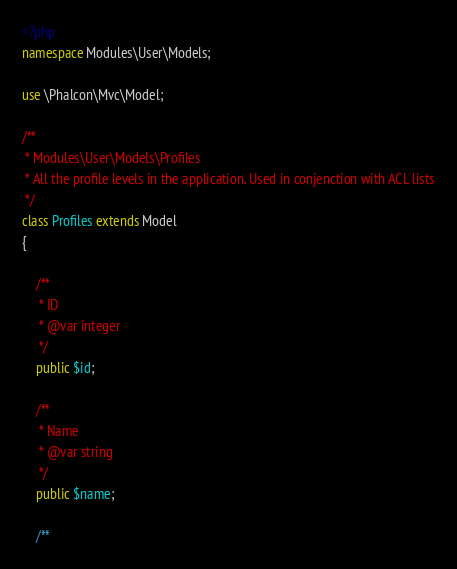<code> <loc_0><loc_0><loc_500><loc_500><_PHP_><?php
namespace Modules\User\Models;

use \Phalcon\Mvc\Model;

/**
 * Modules\User\Models\Profiles
 * All the profile levels in the application. Used in conjenction with ACL lists
 */
class Profiles extends Model
{

    /**
     * ID
     * @var integer
     */
    public $id;

    /**
     * Name
     * @var string
     */
    public $name;

    /**</code> 